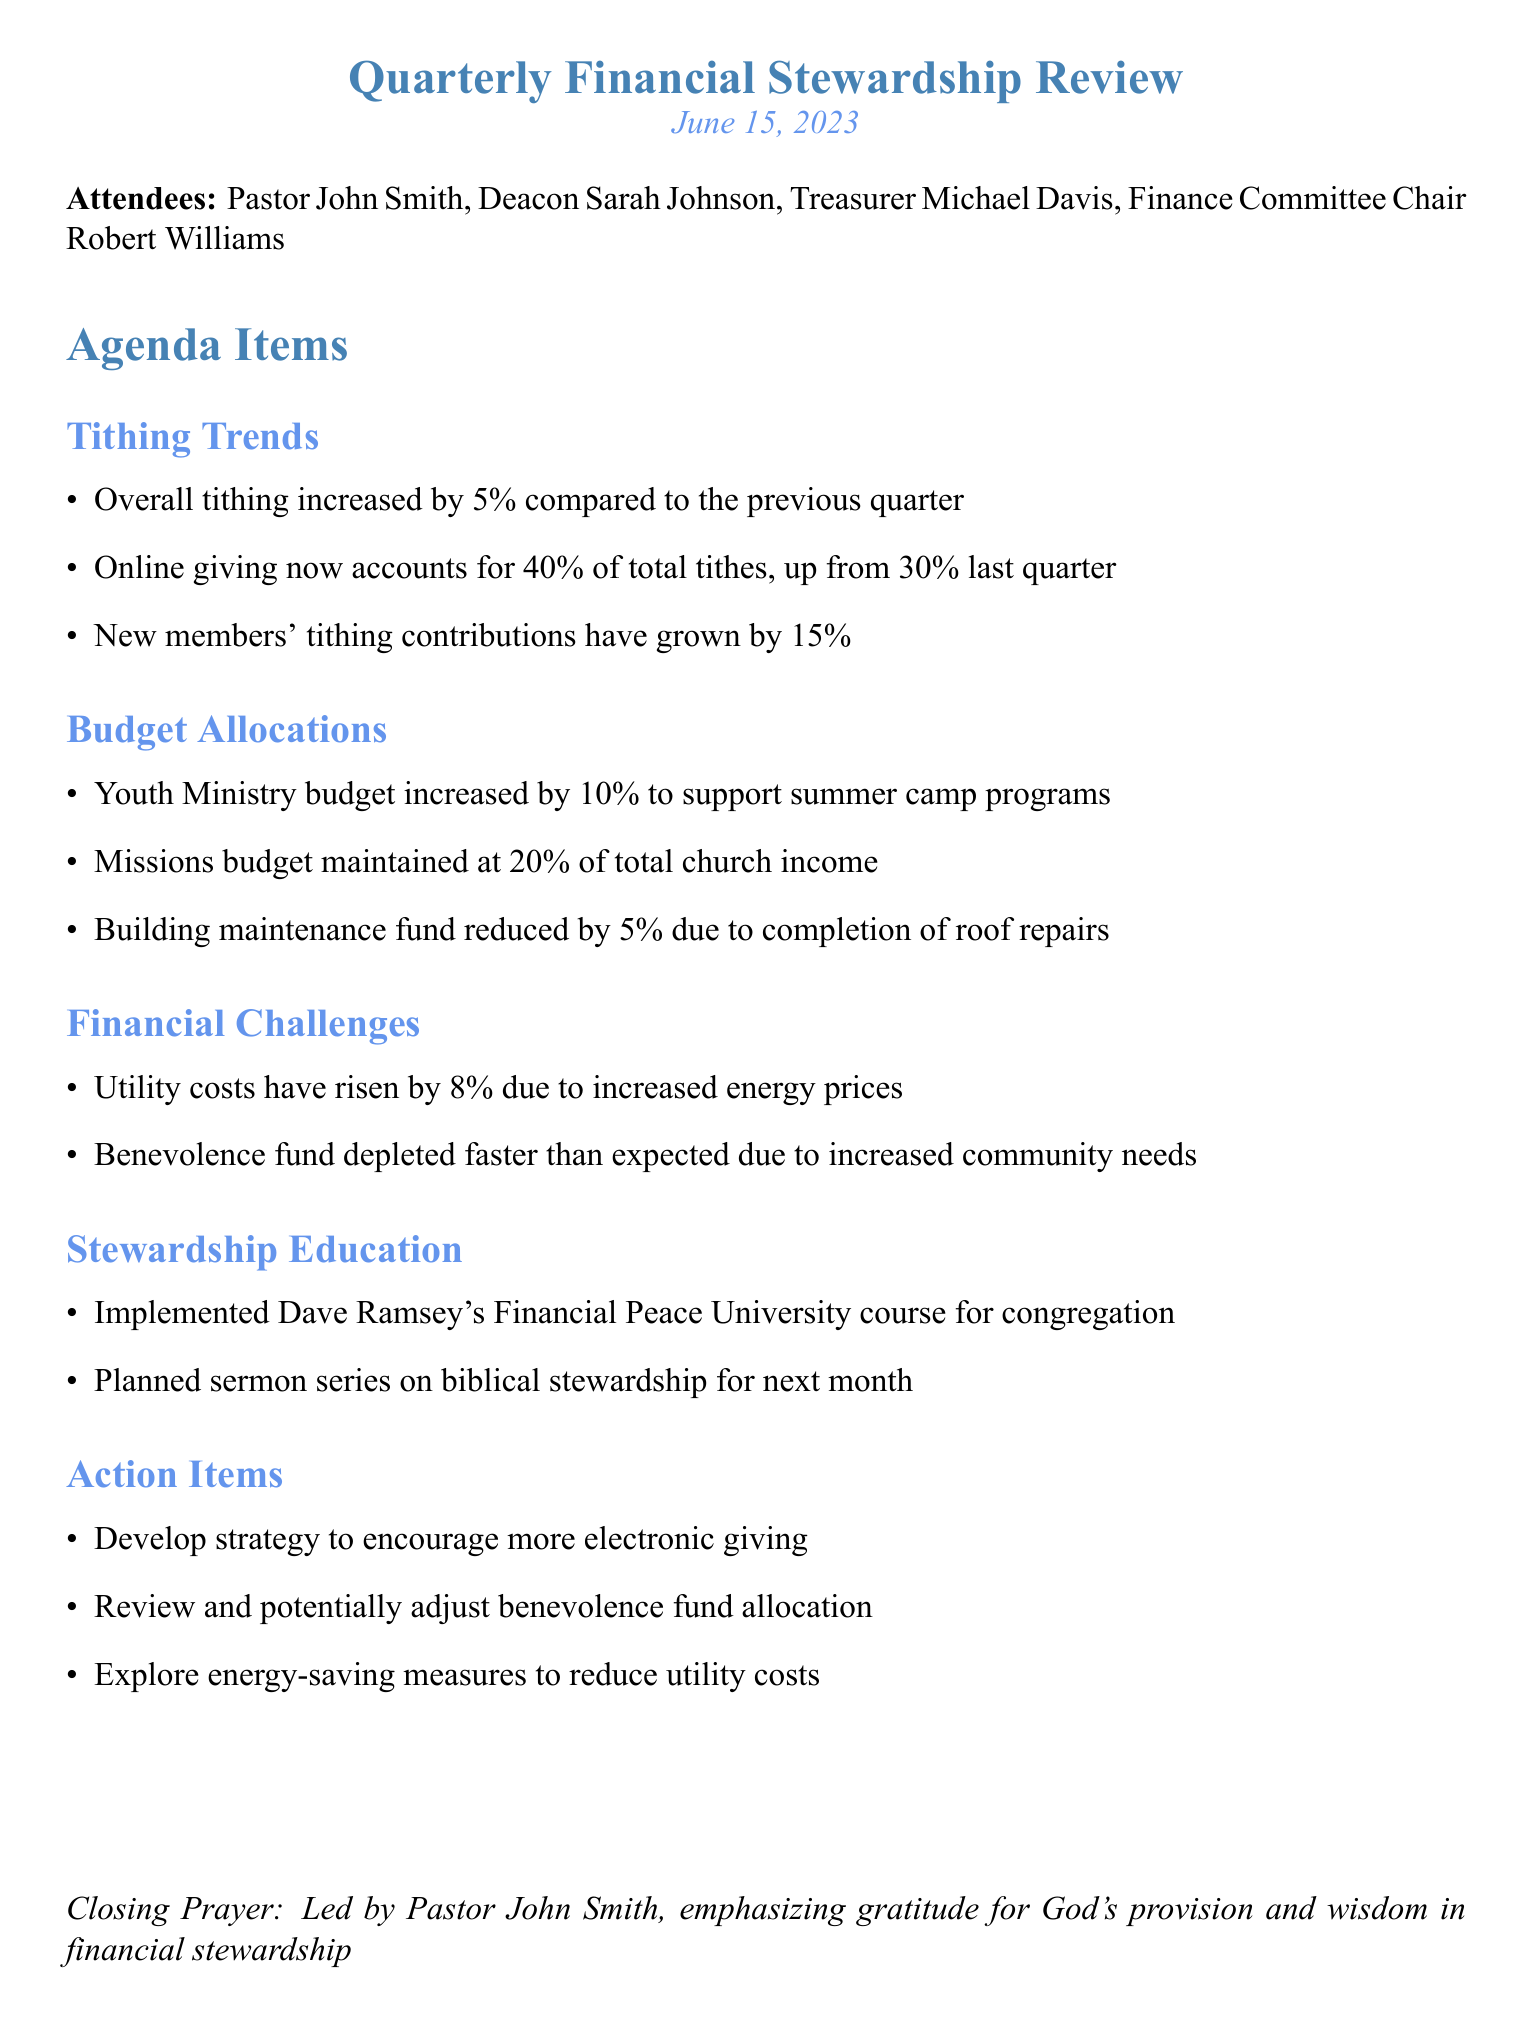What was the date of the meeting? The date of the meeting is mentioned at the beginning of the document.
Answer: June 15, 2023 Who led the closing prayer? The closing prayer is attributed to a specific individual in the document.
Answer: Pastor John Smith What was the percent increase in overall tithing? The document states the percentage increase compared to the previous quarter.
Answer: 5% What portion of total tithes comes from online giving? The document provides the percentage of online giving compared to total tithes.
Answer: 40% What is the budget allocation for the Missions? The document specifies the maintained budget percentage for Missions.
Answer: 20% of total church income What are the anticipated energy cost changes? The document notes the trend in utility costs and the specific percentage increase.
Answer: 8% What strategy is to be developed regarding giving? The action items list a specific strategy to be encouraged.
Answer: More electronic giving What is one challenge mentioned regarding the benevolence fund? The document highlights a specific issue faced concerning the benevolence fund.
Answer: Depleted faster than expected What is one educational initiative planned for the congregation? The document describes a specific stewardship education implementation.
Answer: Financial Peace University course 